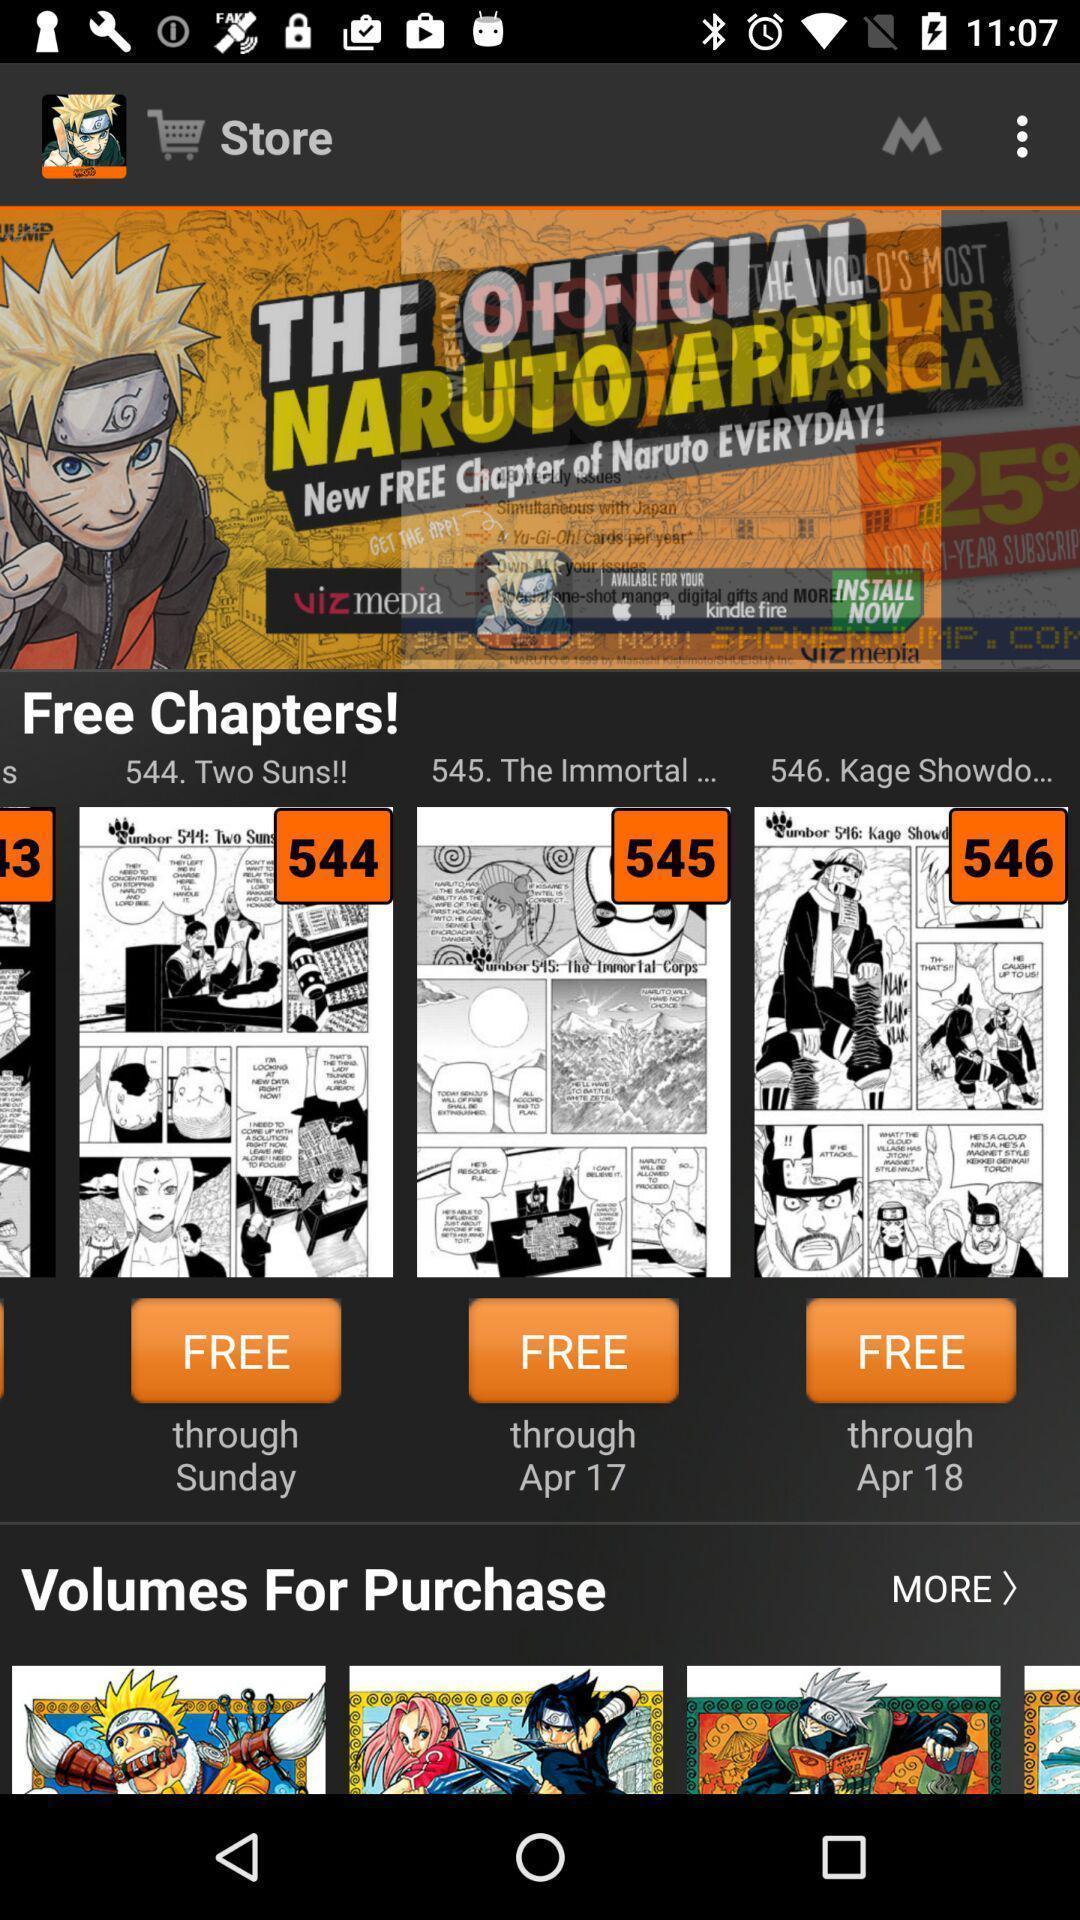Describe this image in words. Page displaying various series of cartoons. 